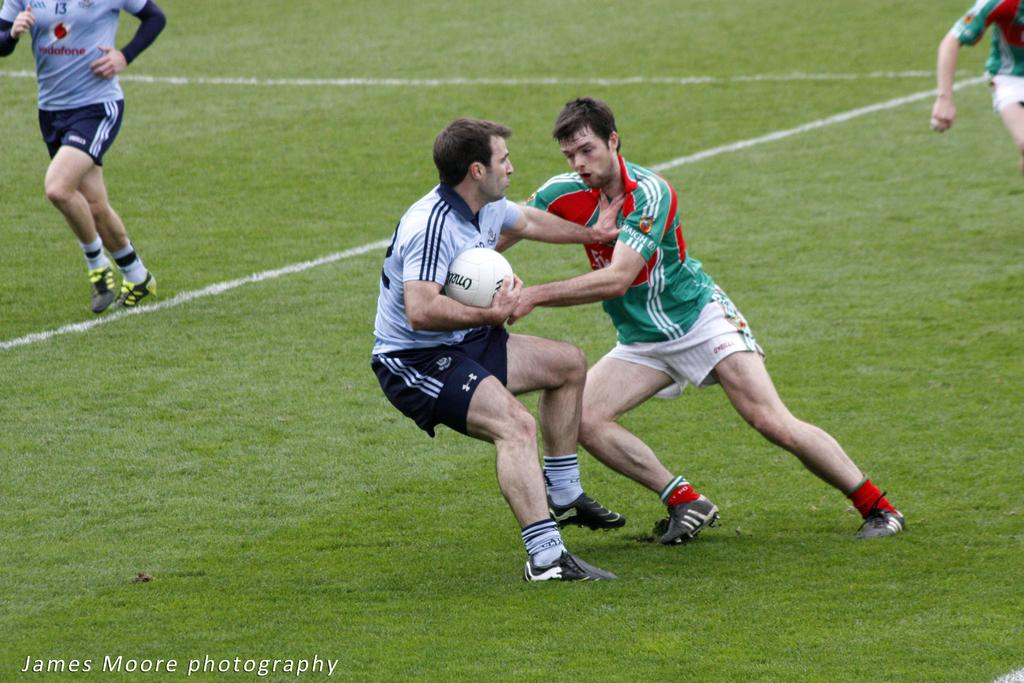How many people are present in the image? There are four people in the image. What are the people doing in the image? The people are playing a game. Can you describe the object being held by one of the individuals? Yes, a man is holding a ball. Is there any additional information about the image itself? There is a watermark on the image. What type of horn can be heard in the image? There is no horn present in the image, and therefore no sound can be heard. 